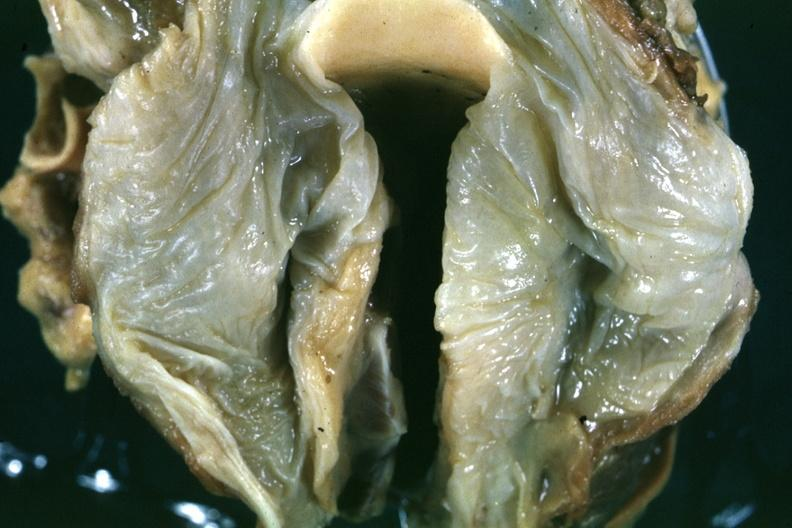what is a close-up in natural color of the edematous mucosal membrane?
Answer the question using a single word or phrase. Slide 